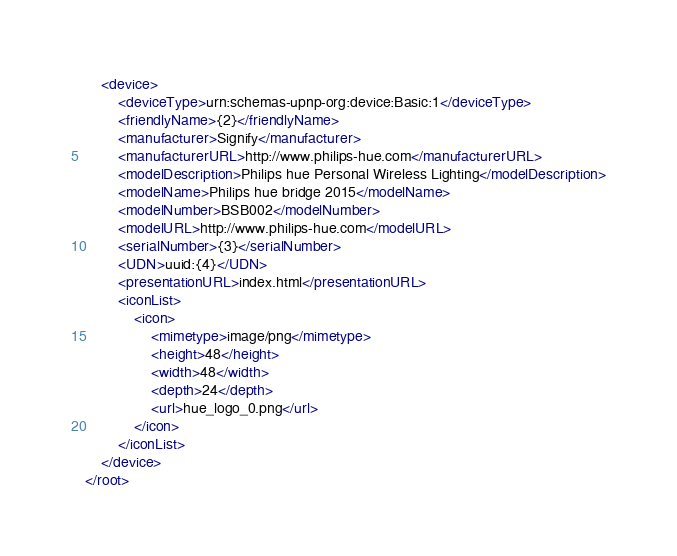<code> <loc_0><loc_0><loc_500><loc_500><_XML_>    <device>
        <deviceType>urn:schemas-upnp-org:device:Basic:1</deviceType>
        <friendlyName>{2}</friendlyName>
        <manufacturer>Signify</manufacturer>
        <manufacturerURL>http://www.philips-hue.com</manufacturerURL>
        <modelDescription>Philips hue Personal Wireless Lighting</modelDescription>
        <modelName>Philips hue bridge 2015</modelName>
        <modelNumber>BSB002</modelNumber>
        <modelURL>http://www.philips-hue.com</modelURL>
        <serialNumber>{3}</serialNumber>
        <UDN>uuid:{4}</UDN>
        <presentationURL>index.html</presentationURL>
        <iconList>
            <icon>
                <mimetype>image/png</mimetype>
                <height>48</height>
                <width>48</width>
                <depth>24</depth>
                <url>hue_logo_0.png</url>
            </icon>
        </iconList>
    </device>
</root></code> 